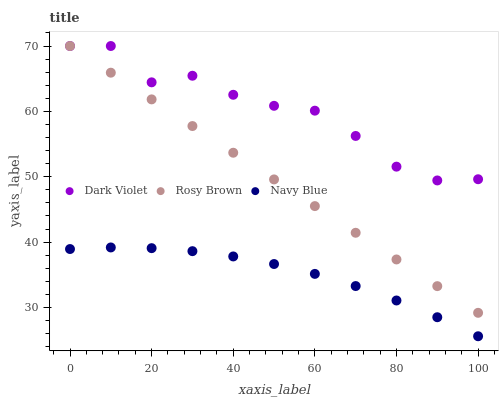Does Navy Blue have the minimum area under the curve?
Answer yes or no. Yes. Does Dark Violet have the maximum area under the curve?
Answer yes or no. Yes. Does Rosy Brown have the minimum area under the curve?
Answer yes or no. No. Does Rosy Brown have the maximum area under the curve?
Answer yes or no. No. Is Rosy Brown the smoothest?
Answer yes or no. Yes. Is Dark Violet the roughest?
Answer yes or no. Yes. Is Dark Violet the smoothest?
Answer yes or no. No. Is Rosy Brown the roughest?
Answer yes or no. No. Does Navy Blue have the lowest value?
Answer yes or no. Yes. Does Rosy Brown have the lowest value?
Answer yes or no. No. Does Dark Violet have the highest value?
Answer yes or no. Yes. Is Navy Blue less than Rosy Brown?
Answer yes or no. Yes. Is Dark Violet greater than Navy Blue?
Answer yes or no. Yes. Does Rosy Brown intersect Dark Violet?
Answer yes or no. Yes. Is Rosy Brown less than Dark Violet?
Answer yes or no. No. Is Rosy Brown greater than Dark Violet?
Answer yes or no. No. Does Navy Blue intersect Rosy Brown?
Answer yes or no. No. 